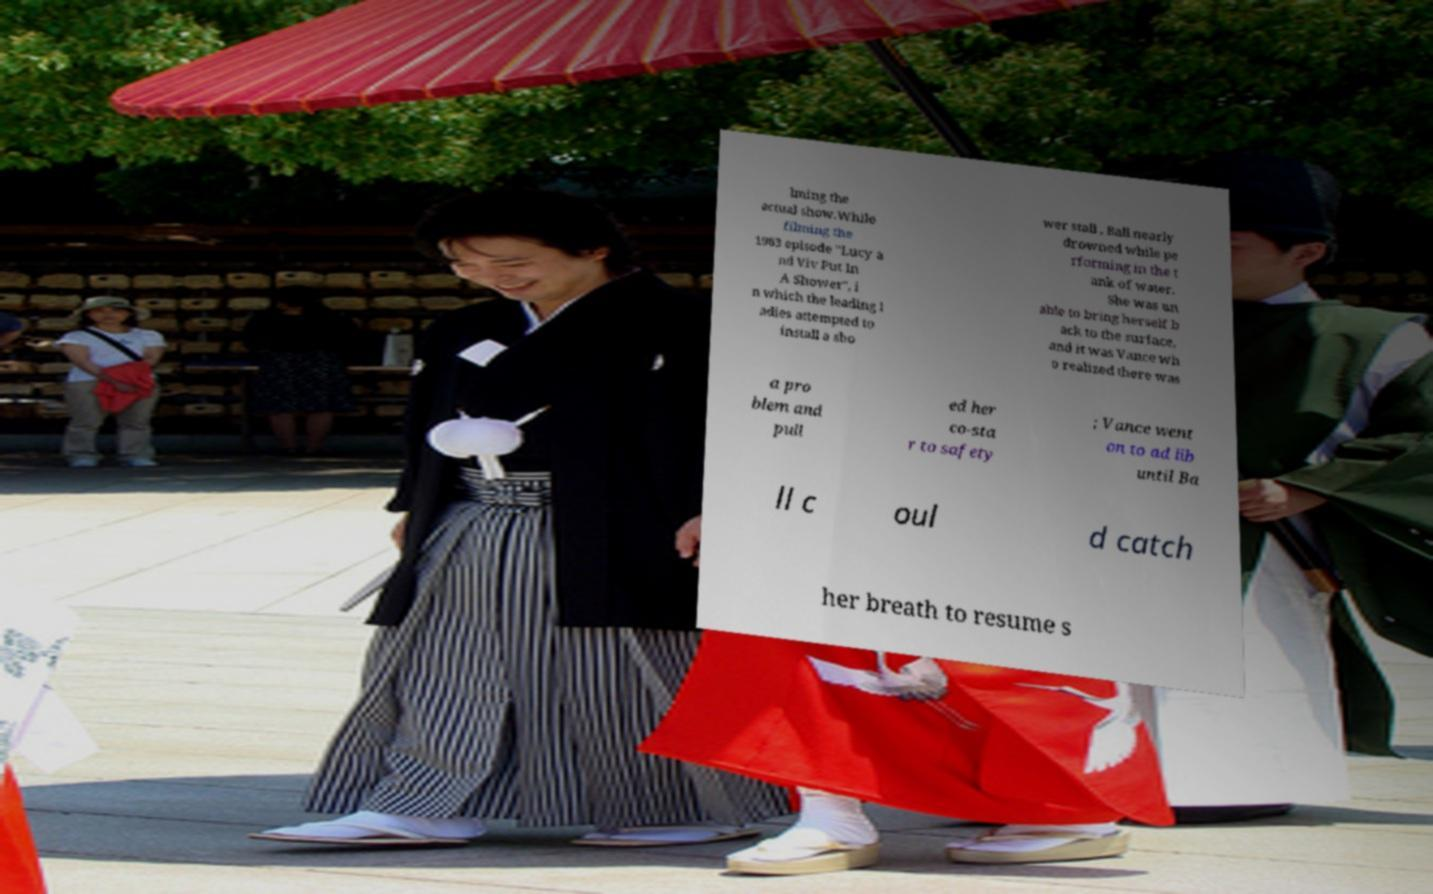I need the written content from this picture converted into text. Can you do that? lming the actual show.While filming the 1963 episode "Lucy a nd Viv Put In A Shower", i n which the leading l adies attempted to install a sho wer stall , Ball nearly drowned while pe rforming in the t ank of water. She was un able to bring herself b ack to the surface, and it was Vance wh o realized there was a pro blem and pull ed her co-sta r to safety ; Vance went on to ad lib until Ba ll c oul d catch her breath to resume s 